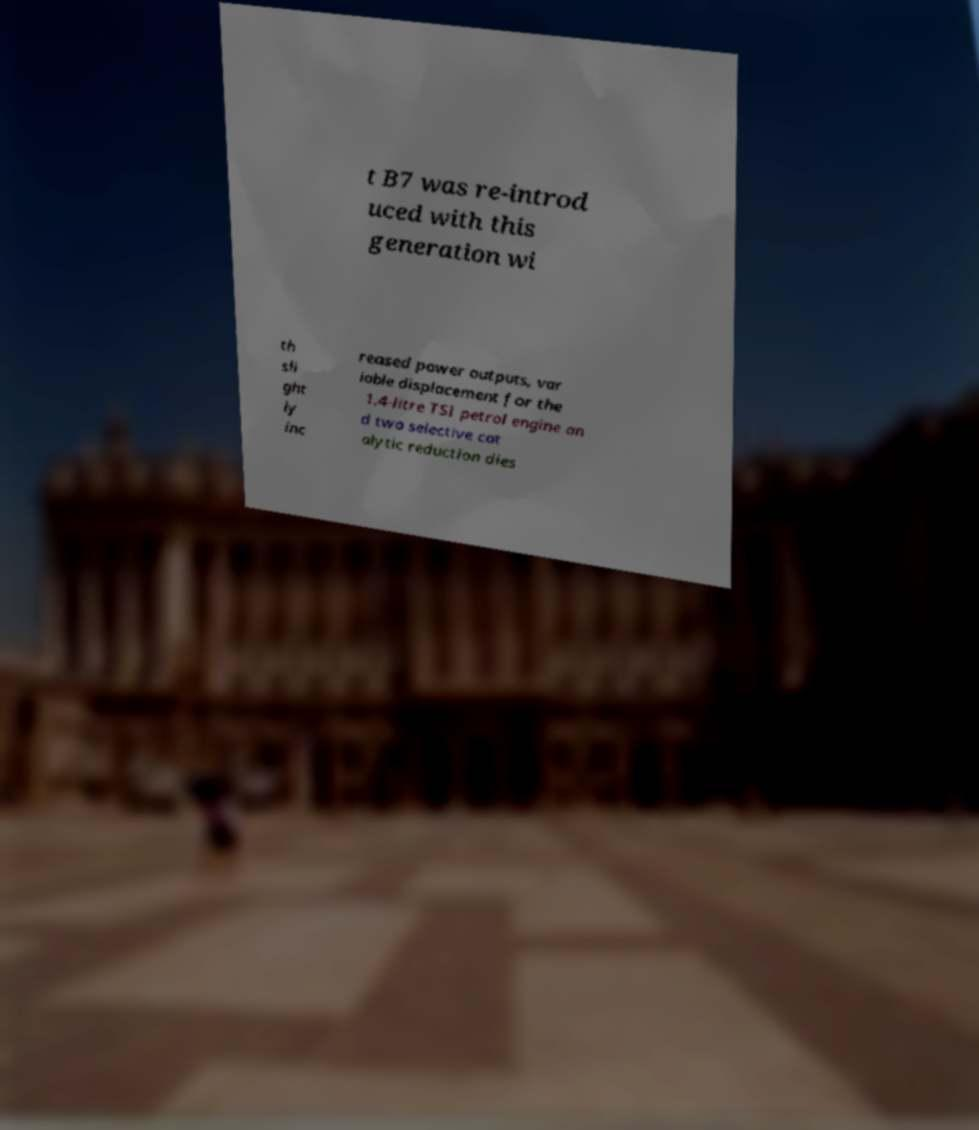There's text embedded in this image that I need extracted. Can you transcribe it verbatim? t B7 was re-introd uced with this generation wi th sli ght ly inc reased power outputs, var iable displacement for the 1.4-litre TSI petrol engine an d two selective cat alytic reduction dies 